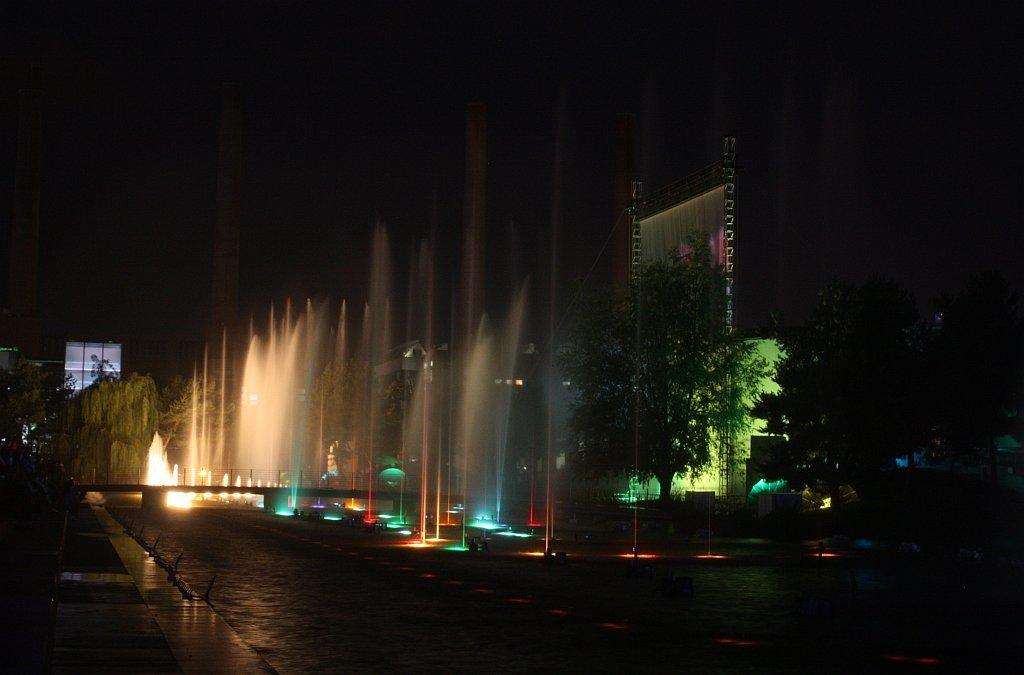What type of structures are present in the image? There are water fountains, lights, poles, and a bridge in the image. What type of natural elements can be seen in the image? There are trees in the image. What objects are present in the image? There are objects in the image, but their specific nature is not mentioned in the facts. What is the lighting situation on the right side of the image? The right side of the image is completely dark. Can you see a net being used to catch fish in the image? There is no mention of a net or fishing in the image, so it cannot be seen. Is there a guide leading a group of people through the area in the image? There is no mention of a guide or a group of people in the image, so it cannot be determined. 